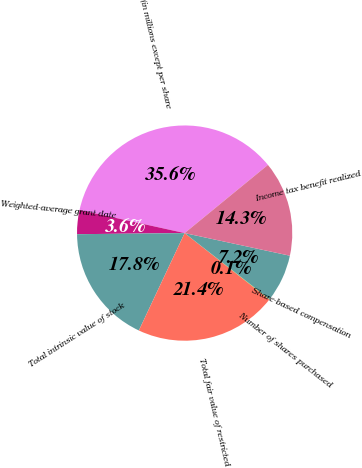Convert chart to OTSL. <chart><loc_0><loc_0><loc_500><loc_500><pie_chart><fcel>(in millions except per share<fcel>Weighted-average grant date<fcel>Total intrinsic value of stock<fcel>Total fair value of restricted<fcel>Number of shares purchased<fcel>Share-based compensation<fcel>Income tax benefit realized<nl><fcel>35.63%<fcel>3.61%<fcel>17.84%<fcel>21.4%<fcel>0.05%<fcel>7.17%<fcel>14.29%<nl></chart> 